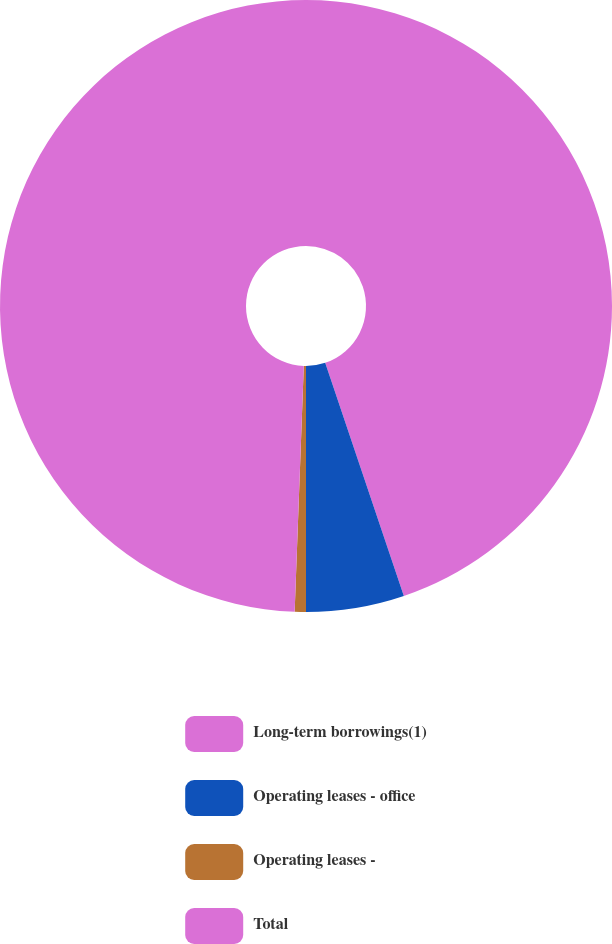<chart> <loc_0><loc_0><loc_500><loc_500><pie_chart><fcel>Long-term borrowings(1)<fcel>Operating leases - office<fcel>Operating leases -<fcel>Total<nl><fcel>44.82%<fcel>5.18%<fcel>0.59%<fcel>49.41%<nl></chart> 